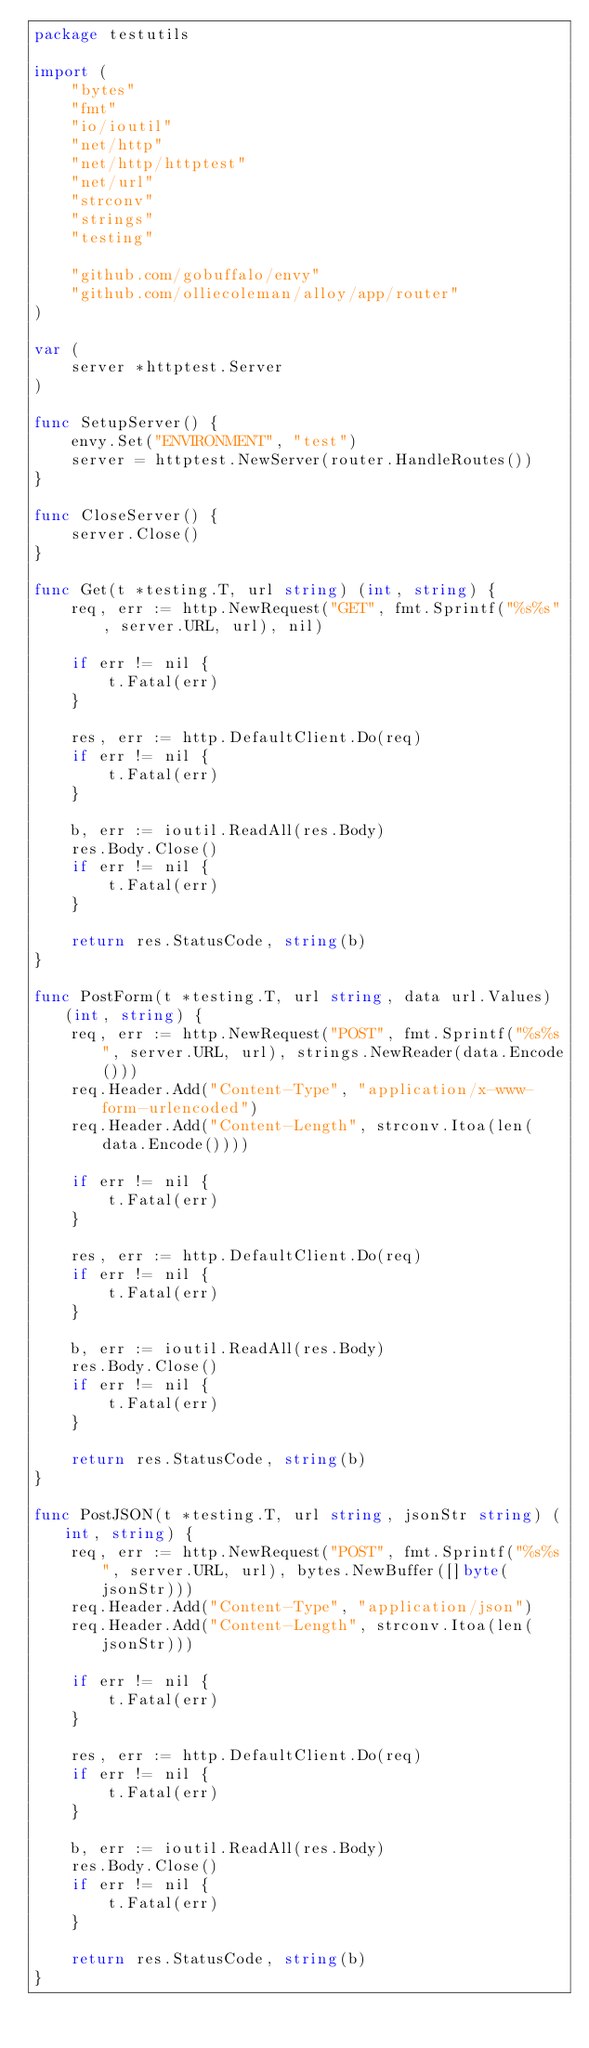<code> <loc_0><loc_0><loc_500><loc_500><_Go_>package testutils

import (
	"bytes"
	"fmt"
	"io/ioutil"
	"net/http"
	"net/http/httptest"
	"net/url"
	"strconv"
	"strings"
	"testing"

	"github.com/gobuffalo/envy"
	"github.com/olliecoleman/alloy/app/router"
)

var (
	server *httptest.Server
)

func SetupServer() {
	envy.Set("ENVIRONMENT", "test")
	server = httptest.NewServer(router.HandleRoutes())
}

func CloseServer() {
	server.Close()
}

func Get(t *testing.T, url string) (int, string) {
	req, err := http.NewRequest("GET", fmt.Sprintf("%s%s", server.URL, url), nil)

	if err != nil {
		t.Fatal(err)
	}

	res, err := http.DefaultClient.Do(req)
	if err != nil {
		t.Fatal(err)
	}

	b, err := ioutil.ReadAll(res.Body)
	res.Body.Close()
	if err != nil {
		t.Fatal(err)
	}

	return res.StatusCode, string(b)
}

func PostForm(t *testing.T, url string, data url.Values) (int, string) {
	req, err := http.NewRequest("POST", fmt.Sprintf("%s%s", server.URL, url), strings.NewReader(data.Encode()))
	req.Header.Add("Content-Type", "application/x-www-form-urlencoded")
	req.Header.Add("Content-Length", strconv.Itoa(len(data.Encode())))

	if err != nil {
		t.Fatal(err)
	}

	res, err := http.DefaultClient.Do(req)
	if err != nil {
		t.Fatal(err)
	}

	b, err := ioutil.ReadAll(res.Body)
	res.Body.Close()
	if err != nil {
		t.Fatal(err)
	}

	return res.StatusCode, string(b)
}

func PostJSON(t *testing.T, url string, jsonStr string) (int, string) {
	req, err := http.NewRequest("POST", fmt.Sprintf("%s%s", server.URL, url), bytes.NewBuffer([]byte(jsonStr)))
	req.Header.Add("Content-Type", "application/json")
	req.Header.Add("Content-Length", strconv.Itoa(len(jsonStr)))

	if err != nil {
		t.Fatal(err)
	}

	res, err := http.DefaultClient.Do(req)
	if err != nil {
		t.Fatal(err)
	}

	b, err := ioutil.ReadAll(res.Body)
	res.Body.Close()
	if err != nil {
		t.Fatal(err)
	}

	return res.StatusCode, string(b)
}
</code> 